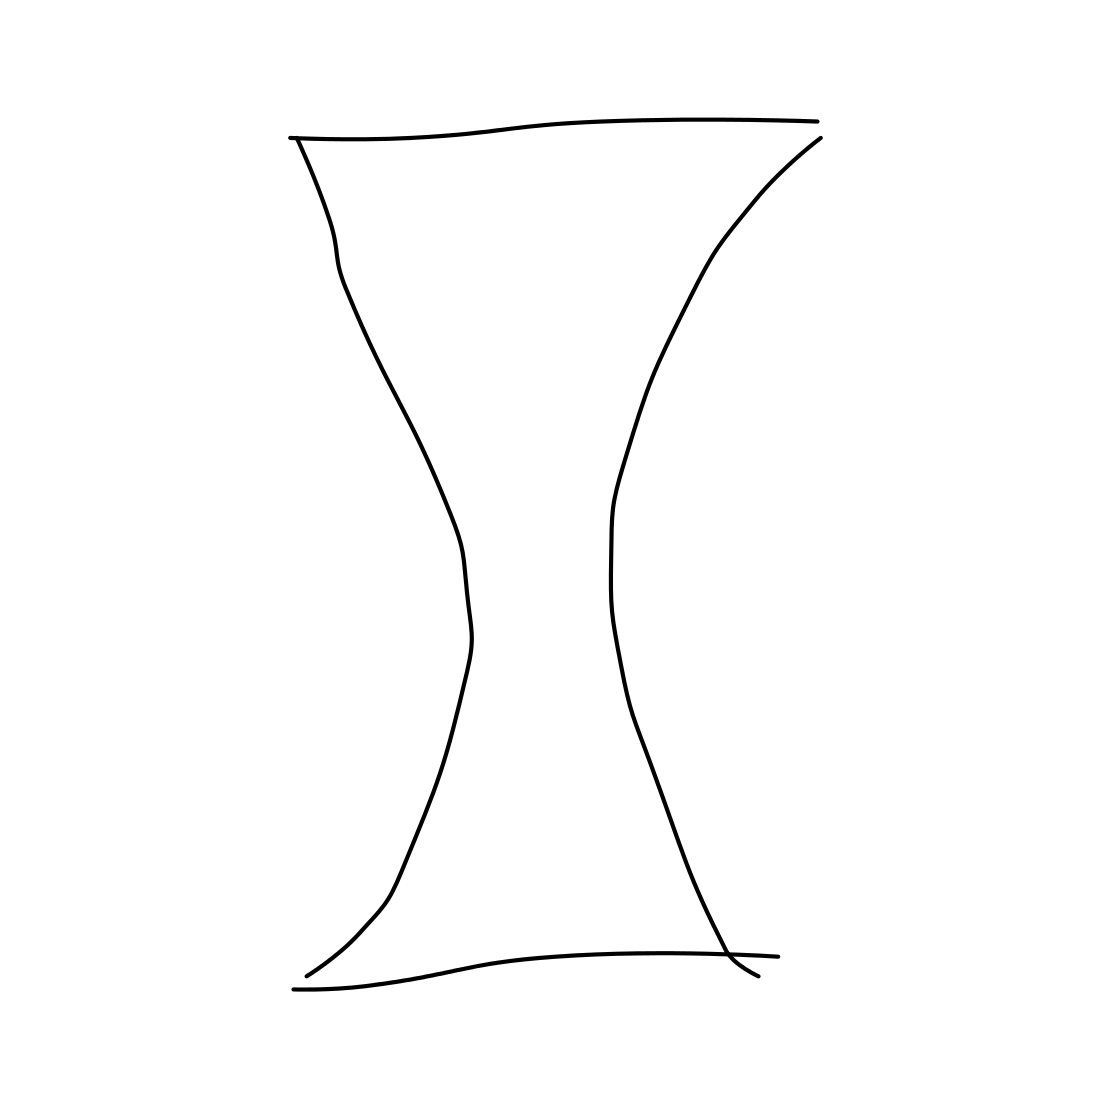Is this an apple in the image? No, the image does not feature an apple. It depicts a simple line drawing of a symmetrical, hourglass-like shape. 